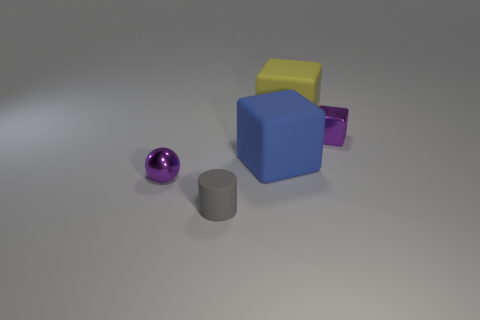Subtract all yellow cubes. How many cubes are left? 2 Add 1 small purple objects. How many objects exist? 6 Subtract 1 blocks. How many blocks are left? 2 Subtract all blocks. How many objects are left? 2 Subtract all red spheres. Subtract all purple cylinders. How many spheres are left? 1 Subtract all small red metallic balls. Subtract all cylinders. How many objects are left? 4 Add 5 small gray objects. How many small gray objects are left? 6 Add 3 small cubes. How many small cubes exist? 4 Subtract 0 cyan blocks. How many objects are left? 5 